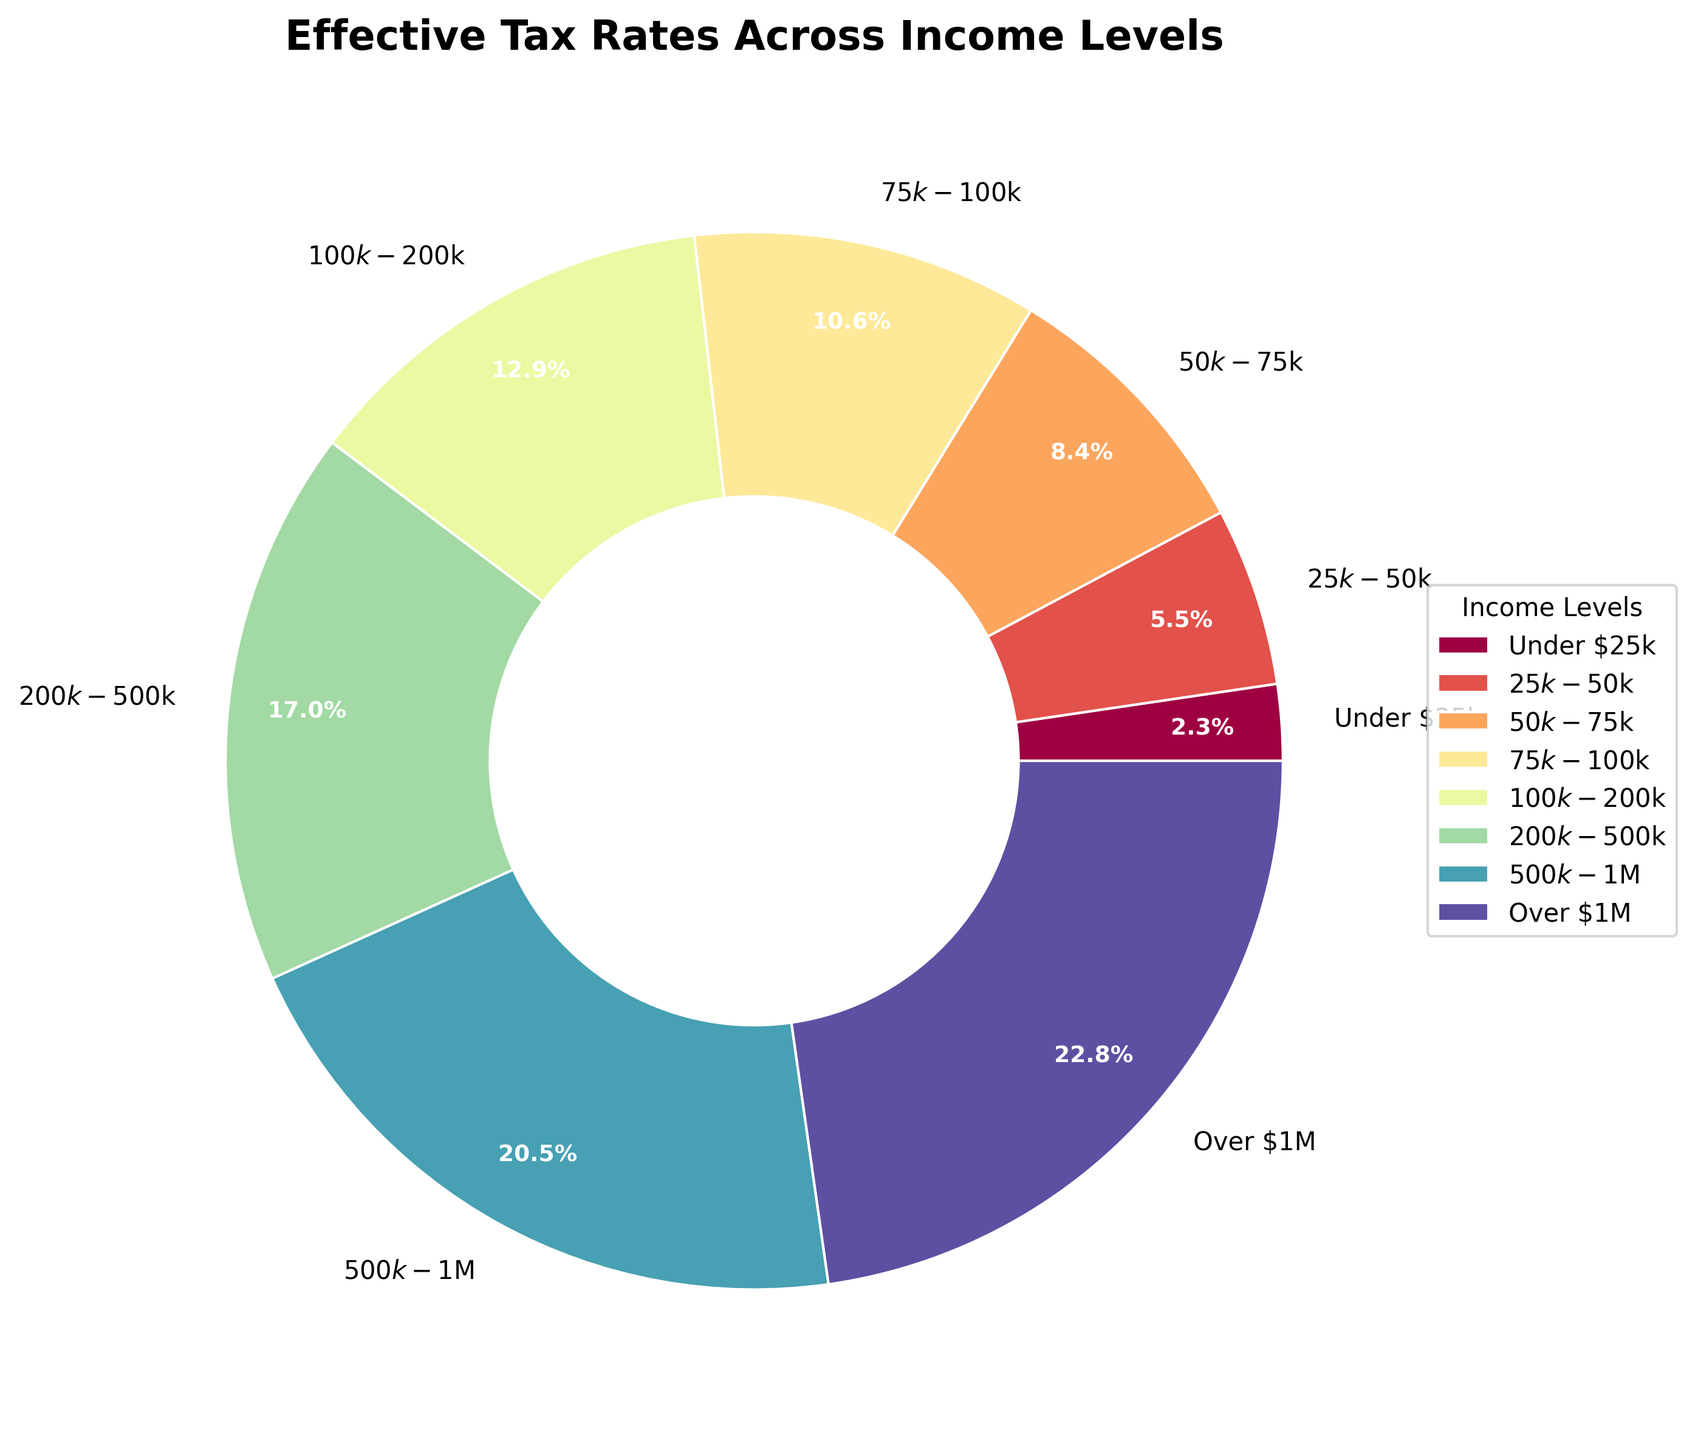What income level has the highest effective tax rate? The slices of the pie chart show different effective tax rates for various income levels. The label with the highest percentage corresponds to the "Over $1M" category.
Answer: Over $1M What are the effective tax rates for income levels under $25k and $500k-$1M? The chart labels each slice with its respective effective tax rate. For the "Under $25k" category, it is 3.5%, and for the "$500k-$1M" category, it is 30.8%.
Answer: 3.5% and 30.8% Which income level has a lower effective tax rate: $75k-$100k or $100k-$200k? By examining the pie chart slices, we see that $75k-$100k has a tax rate of 15.9%, while $100k-$200k has a rate of 19.4%.
Answer: $75k-$100k What's the combined effective tax rate percentage of income levels $50k-$75k and $75k-$100k? Combining the tax rates for $50k-$75k (12.7%) and $75k-$100k (15.9%) involves adding these percentages together: 12.7% + 15.9% = 28.6%.
Answer: 28.6% Which income level shows the biggest jump in effective tax rate when moving from the previous income level? By comparing the sequential percentages, the largest increase is between $200k-$500k (25.6%) and $500k-$1M (30.8%). The difference is 30.8% - 25.6% = 5.2%.
Answer: $500k-$1M Are there more income levels with effective tax rates below 20% or above 20%? The slices indicate four income levels below 20%: Under $25k, $25k-$50k, $50k-$75k, and $75k-$100k. Three levels are above 20%: $200k-$500k, $500k-$1M, and Over $1M.
Answer: Below 20% What is the percentage difference in effective tax rates between the lowest and highest income levels? The chart shows 3.5% for Under $25k and 34.2% for Over $1M. The percentage difference is 34.2% - 3.5% = 30.7%.
Answer: 30.7% What color is used for the effective tax rate of income level $100k-$200k? The chart uses colors for different slices, with $100k-$200k marked in a specific shade visible in the pie. According to our color spectrum indexing, this slice appears in a distinctive purple shade.
Answer: Purple What is the average effective tax rate for all the income levels combined? Summing all tax rates: 3.5% + 8.2% + 12.7% + 15.9% + 19.4% + 25.6% + 30.8% + 34.2% = 150.3%. There are 8 income levels, so the average is 150.3% / 8 = 18.79%.
Answer: 18.79% Does any income level have the same color as another, and if not, why not? Each slice has a unique color as indicated by the pie chart's distinct segments. The use of a diverse colormap ensures no two slices share the same color.
Answer: No, each has a unique color 